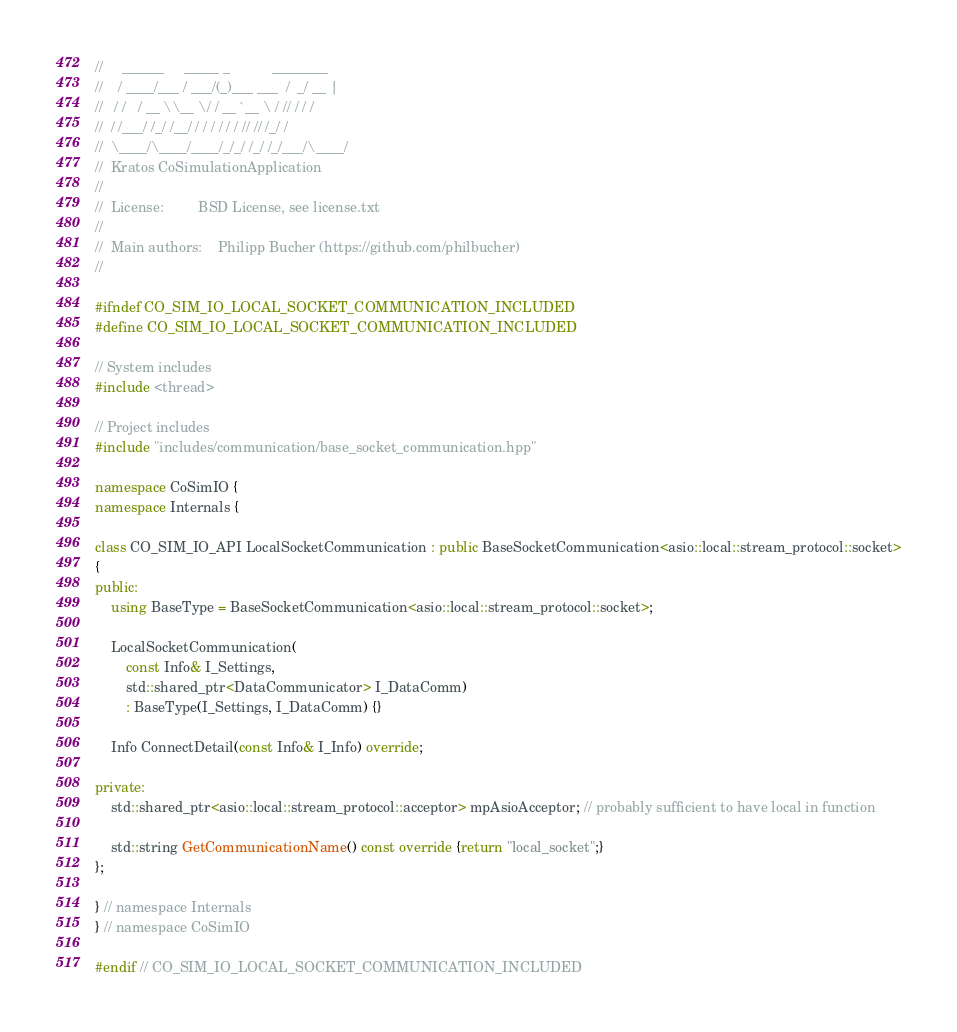<code> <loc_0><loc_0><loc_500><loc_500><_C++_>//     ______     _____ _           ________
//    / ____/___ / ___/(_)___ ___  /  _/ __ |
//   / /   / __ \\__ \/ / __ `__ \ / // / / /
//  / /___/ /_/ /__/ / / / / / / // // /_/ /
//  \____/\____/____/_/_/ /_/ /_/___/\____/
//  Kratos CoSimulationApplication
//
//  License:         BSD License, see license.txt
//
//  Main authors:    Philipp Bucher (https://github.com/philbucher)
//

#ifndef CO_SIM_IO_LOCAL_SOCKET_COMMUNICATION_INCLUDED
#define CO_SIM_IO_LOCAL_SOCKET_COMMUNICATION_INCLUDED

// System includes
#include <thread>

// Project includes
#include "includes/communication/base_socket_communication.hpp"

namespace CoSimIO {
namespace Internals {

class CO_SIM_IO_API LocalSocketCommunication : public BaseSocketCommunication<asio::local::stream_protocol::socket>
{
public:
    using BaseType = BaseSocketCommunication<asio::local::stream_protocol::socket>;

    LocalSocketCommunication(
        const Info& I_Settings,
        std::shared_ptr<DataCommunicator> I_DataComm)
        : BaseType(I_Settings, I_DataComm) {}

    Info ConnectDetail(const Info& I_Info) override;

private:
    std::shared_ptr<asio::local::stream_protocol::acceptor> mpAsioAcceptor; // probably sufficient to have local in function

    std::string GetCommunicationName() const override {return "local_socket";}
};

} // namespace Internals
} // namespace CoSimIO

#endif // CO_SIM_IO_LOCAL_SOCKET_COMMUNICATION_INCLUDED
</code> 